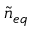Convert formula to latex. <formula><loc_0><loc_0><loc_500><loc_500>\tilde { n } _ { e q }</formula> 